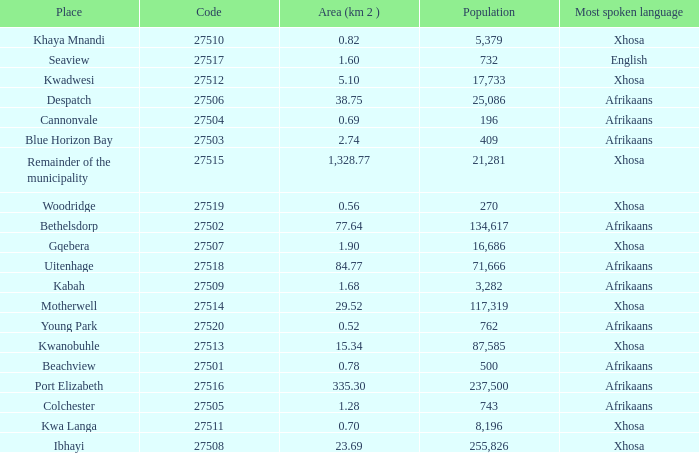What is the lowest code number for the remainder of the municipality that has an area bigger than 15.34 squared kilometers, a population greater than 762 and a language of xhosa spoken? 27515.0. 